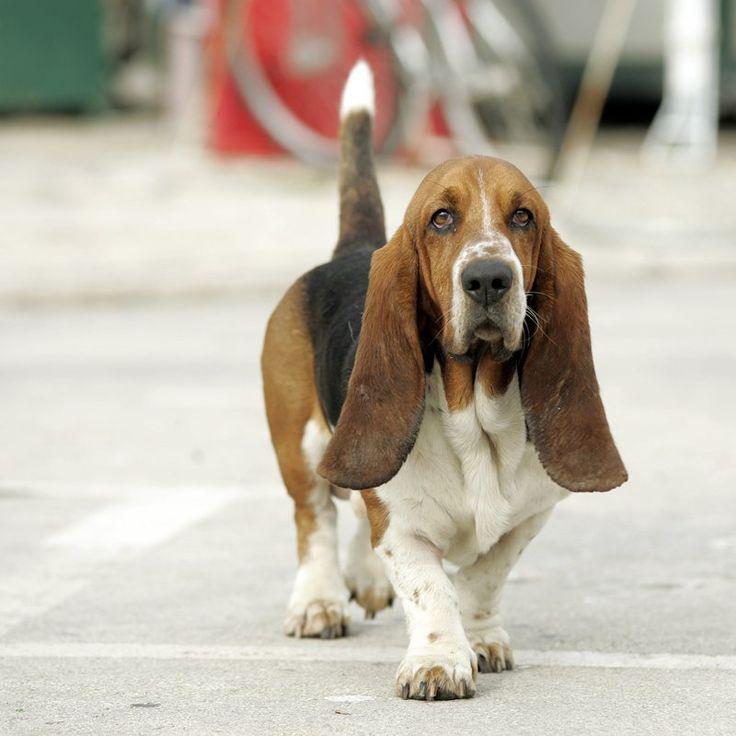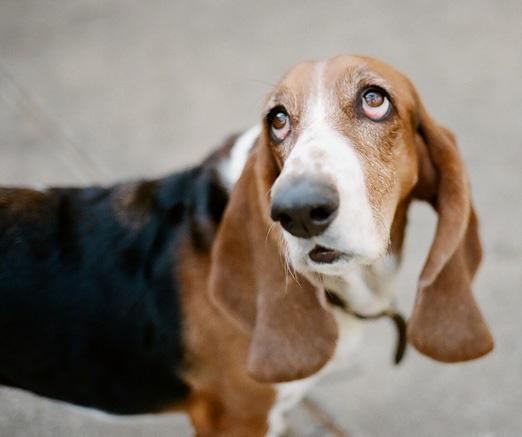The first image is the image on the left, the second image is the image on the right. For the images shown, is this caption "One dog is reclining and one is sitting, and there are only two animals in total." true? Answer yes or no. No. The first image is the image on the left, the second image is the image on the right. For the images shown, is this caption "The right image shows a single dog sitting." true? Answer yes or no. No. 